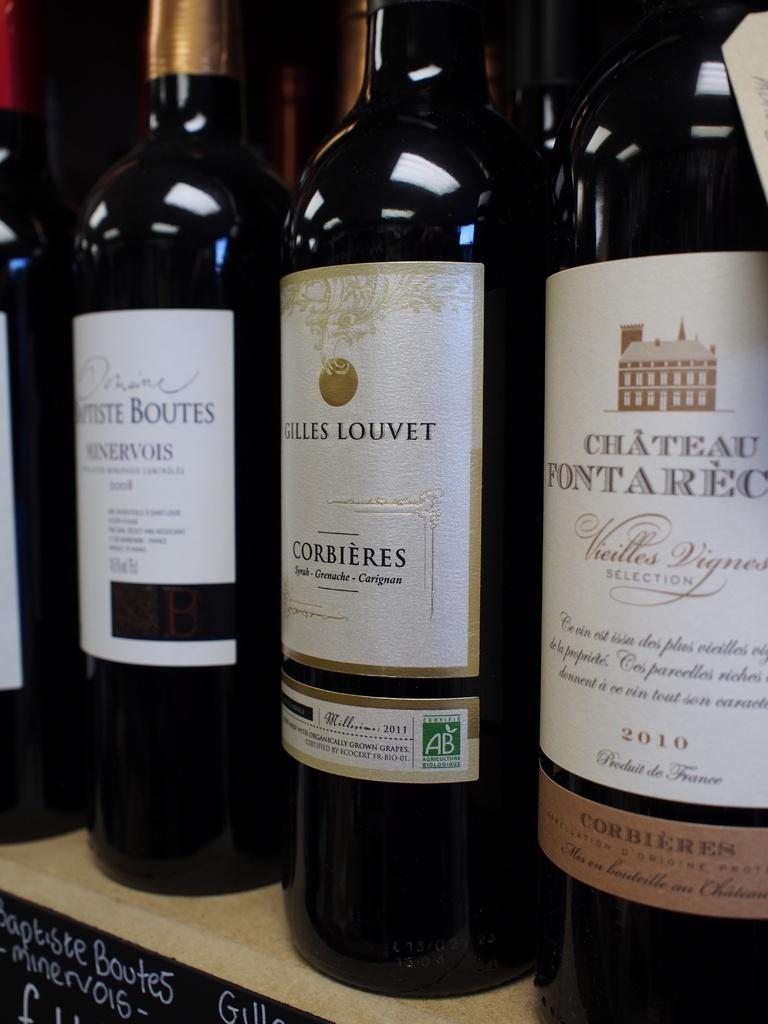<image>
Relay a brief, clear account of the picture shown. Several bottles of wine are together, including a bottle of "Chateau Fontarec." 